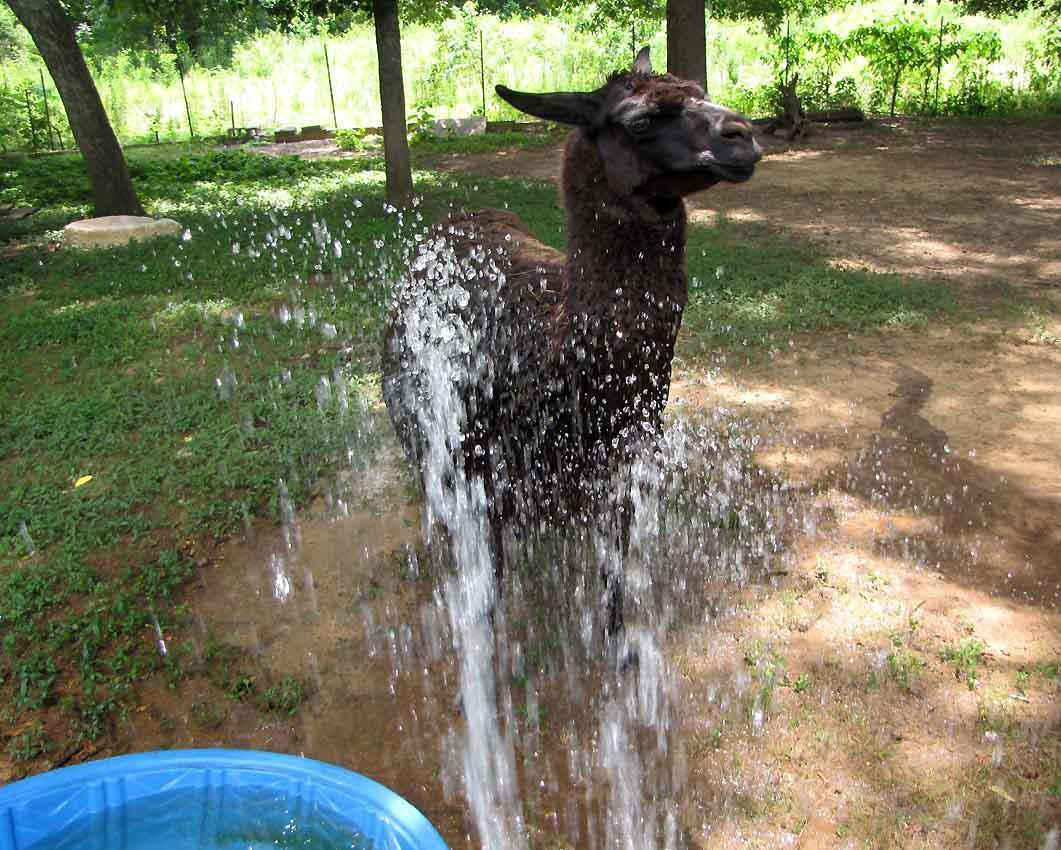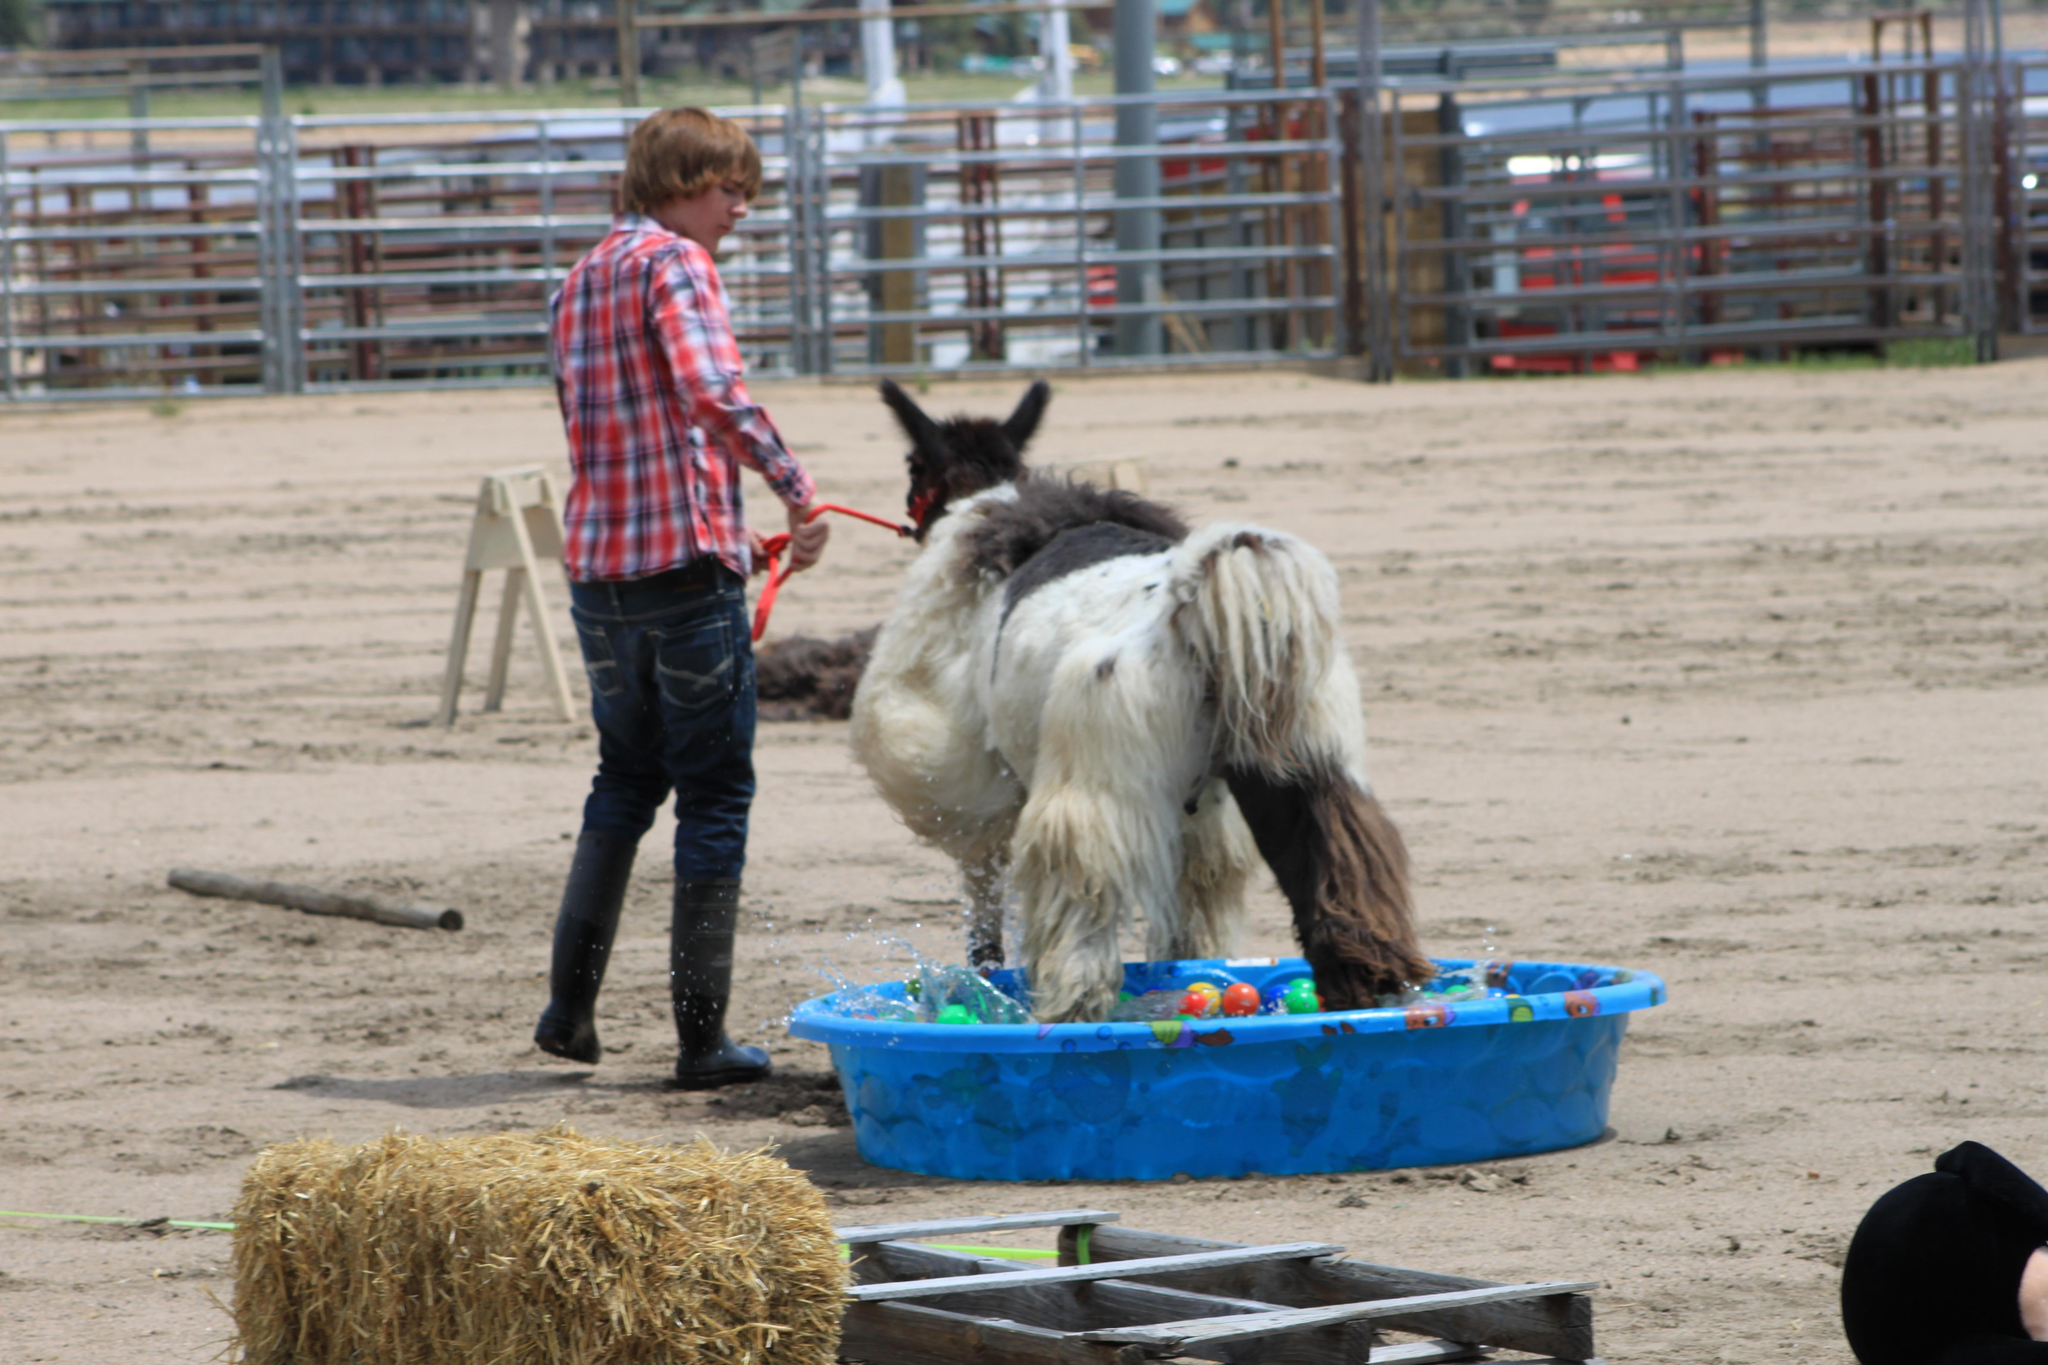The first image is the image on the left, the second image is the image on the right. Evaluate the accuracy of this statement regarding the images: "A forward-turned llama is behind a blue swimming pool in the lefthand image.". Is it true? Answer yes or no. Yes. The first image is the image on the left, the second image is the image on the right. Given the left and right images, does the statement "The left image contains no more than one llama." hold true? Answer yes or no. Yes. 